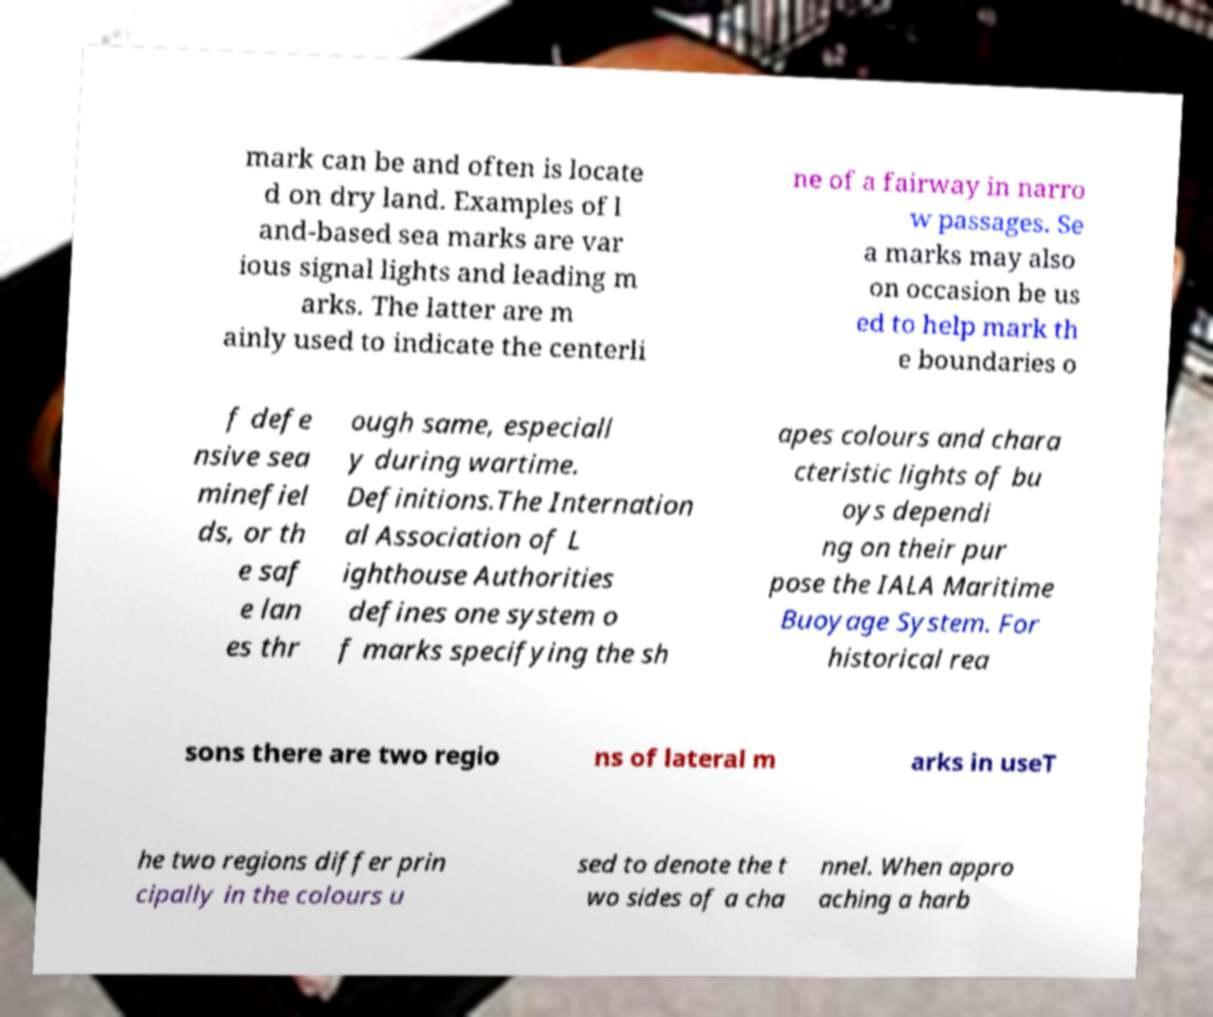What messages or text are displayed in this image? I need them in a readable, typed format. mark can be and often is locate d on dry land. Examples of l and-based sea marks are var ious signal lights and leading m arks. The latter are m ainly used to indicate the centerli ne of a fairway in narro w passages. Se a marks may also on occasion be us ed to help mark th e boundaries o f defe nsive sea minefiel ds, or th e saf e lan es thr ough same, especiall y during wartime. Definitions.The Internation al Association of L ighthouse Authorities defines one system o f marks specifying the sh apes colours and chara cteristic lights of bu oys dependi ng on their pur pose the IALA Maritime Buoyage System. For historical rea sons there are two regio ns of lateral m arks in useT he two regions differ prin cipally in the colours u sed to denote the t wo sides of a cha nnel. When appro aching a harb 